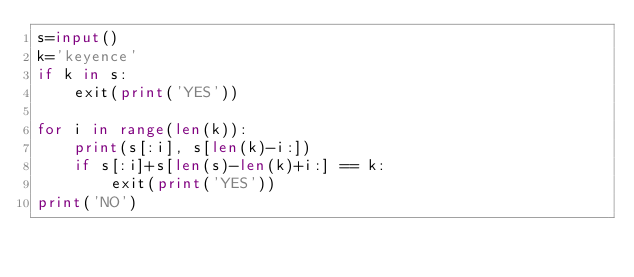Convert code to text. <code><loc_0><loc_0><loc_500><loc_500><_Python_>s=input()
k='keyence'
if k in s:
    exit(print('YES'))

for i in range(len(k)):
    print(s[:i], s[len(k)-i:])
    if s[:i]+s[len(s)-len(k)+i:] == k:
        exit(print('YES'))
print('NO')
</code> 